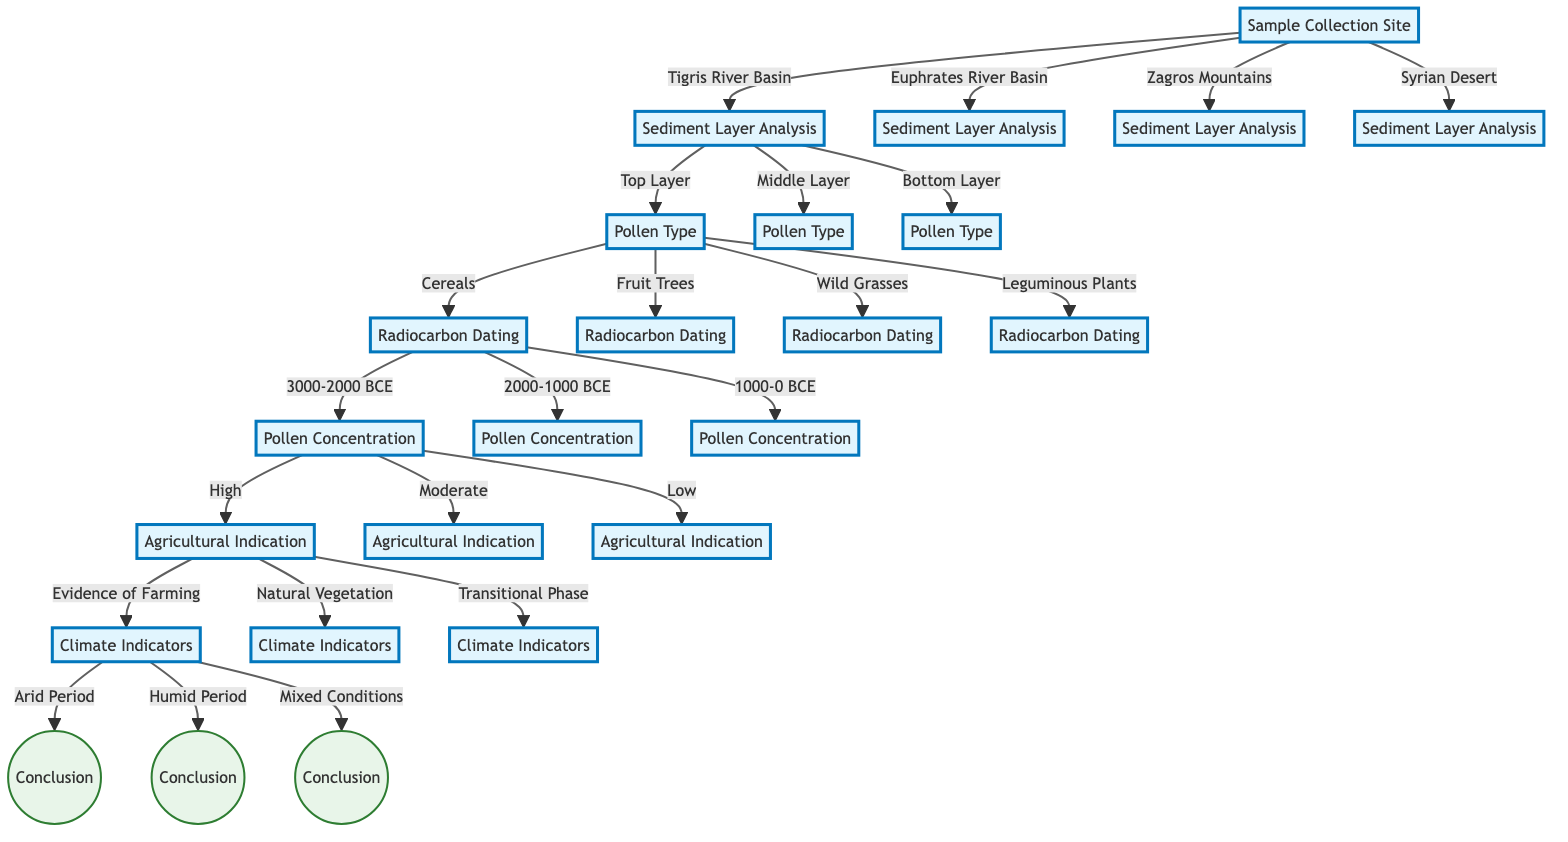What are the possible locations for sample collection? The diagram explicitly lists "Tigris River Basin", "Euphrates River Basin", "Zagros Mountains", and "Syrian Desert" as the options for sample collection.
Answer: Tigris River Basin, Euphrates River Basin, Zagros Mountains, Syrian Desert What is the range of sediment layers that can be analyzed? The decision tree indicates three possible sediment layer analysis options: "Top Layer (1-2 meters)", "Middle Layer (3-5 meters)", and "Bottom Layer (6-8 meters)".
Answer: Top Layer (1-2 meters), Middle Layer (3-5 meters), Bottom Layer (6-8 meters) Which pollen type is linked to the top layer of sediment analysis? According to the diagram, the "Top Layer" leads to four specific pollen types, which are "Cereals", "Fruit Trees", "Wild Grasses", and "Leguminous Plants".
Answer: Cereals, Fruit Trees, Wild Grasses, Leguminous Plants What is the last element in the decision process? The final nodes in the decision tree are the conclusions derived from the climate indicators, which indicate specific climatic conditions associated with various agricultural indications.
Answer: Conclusion If the pollen concentration is low, what could the agricultural indication be? According to the flow in the decision tree, if the pollen concentration is low, the possible agricultural indications include "Evidence of Farming", "Natural Vegetation", or "Transitional Phase", but the final indication can vary with further factors.
Answer: Evidence of Farming, Natural Vegetation, Transitional Phase What is the correlation between high pollen concentration and agricultural indication? The diagram shows that high pollen concentration leads to three paths for agricultural indication, allowing for either "Evidence of Farming", "Natural Vegetation", or "Transitional Phase", which are the outcomes linked to high concentration.
Answer: Evidence of Farming, Natural Vegetation, Transitional Phase What climate indicators may result from evidence of farming? The diagram indicates that evidence of farming can be linked to three climate indicators: "Arid Period", "Humid Period", and "Mixed Conditions".
Answer: Arid Period, Humid Period, Mixed Conditions Which sediment layer directly leads to the analysis of pollen type? The "Top Layer", "Middle Layer", and "Bottom Layer" of sediment analysis connect directly to the pollen type, meaning all layers will eventually lead to information on pollen type analysis.
Answer: Top Layer, Middle Layer, Bottom Layer What is the significance of the radiocarbon dating options in the context of ancient vegetation? The options for radiocarbon dating (ranging from "3000-2000 BCE", "2000-1000 BCE", to "1000-0 BCE") are significant because they help determine the chronological context of the pollen types and their associated agricultural indicators.
Answer: 3000-2000 BCE, 2000-1000 BCE, 1000-0 BCE 